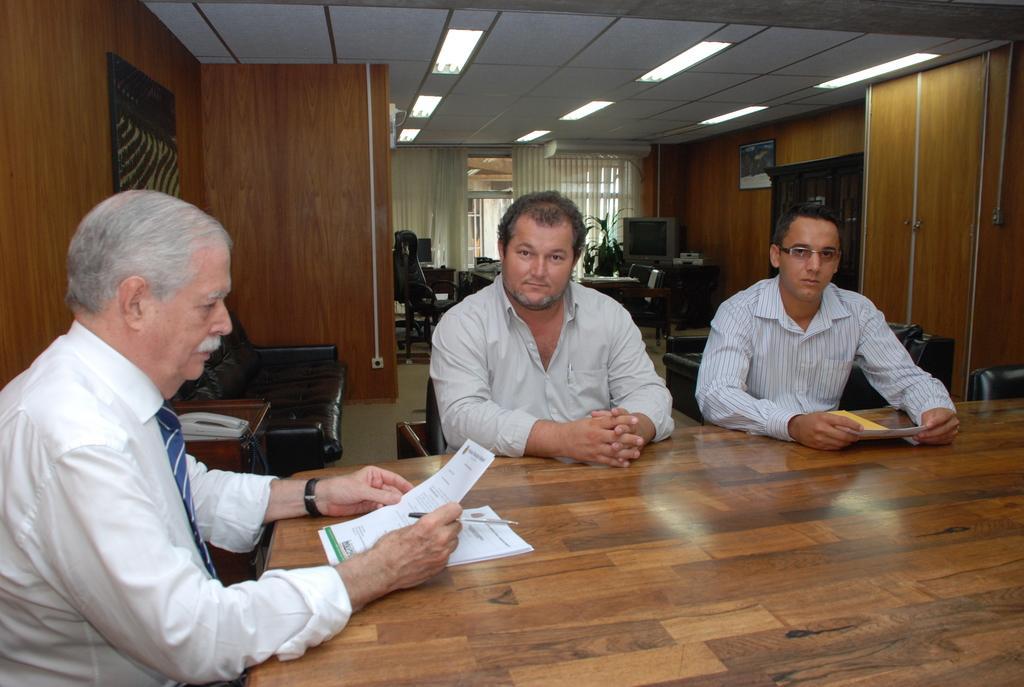Please provide a concise description of this image. There are three persons sitting on the chairs in the middle of this image. We can see the person sitting on the left side is wearing a white color shirt and holding a paper. There is a wooden table at the bottom of this image. There is a black color sofa, some chairs and a television is present in the middle of this image, and there is a curtain on the back side to these chairs. There are some lights at the top of this image, and there is a wooden wall in the background. 